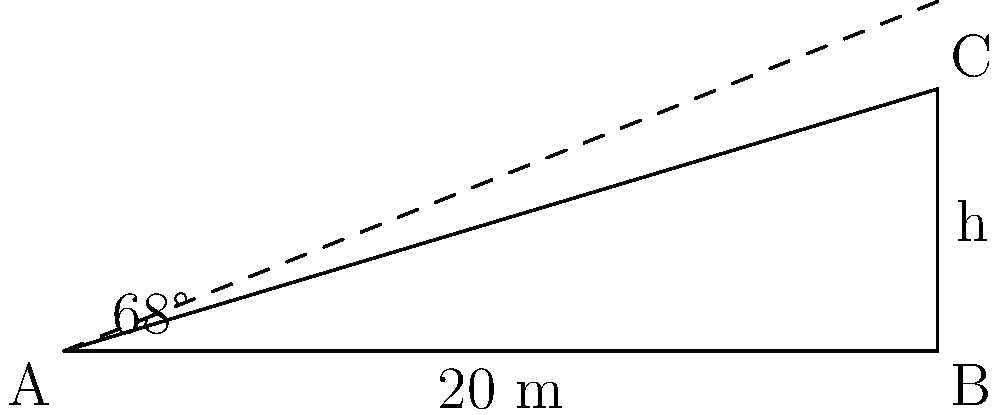As a graphic designer with an eye for precision, you're tasked with creating a billboard for a new skyscraper. To ensure accurate proportions, you need to calculate the building's height. Standing 20 meters from the base, you observe that the angle of elevation to the top of the building is 68°. If your roommate's messy desk were as tall as this building, how high would the clutter stack up? Let's approach this step-by-step, imagining we're arranging elements on a clean canvas:

1) First, let's identify the given information:
   - Distance from the observer to the building: 20 meters
   - Angle of elevation: 68°
   
2) We can visualize this as a right-angled triangle, where:
   - The adjacent side is the distance from the observer to the building (20 m)
   - The opposite side is the height of the building (h)
   - The angle between the ground and the line of sight is 68°

3) In this scenario, we need to use the tangent function, as it relates the opposite and adjacent sides:

   $\tan \theta = \frac{\text{opposite}}{\text{adjacent}}$

4) Plugging in our values:

   $\tan 68° = \frac{h}{20}$

5) To solve for h, we multiply both sides by 20:

   $20 \tan 68° = h$

6) Using a calculator (or appreciating the precision of digital tools):

   $h = 20 \times \tan 68° \approx 49.0087 \text{ meters}$

7) Rounding to two decimal places for a clean design:

   $h \approx 49.01 \text{ meters}$

Thus, if your roommate's messy desk were as tall as this building, the clutter would stack up to about 49.01 meters!
Answer: 49.01 meters 